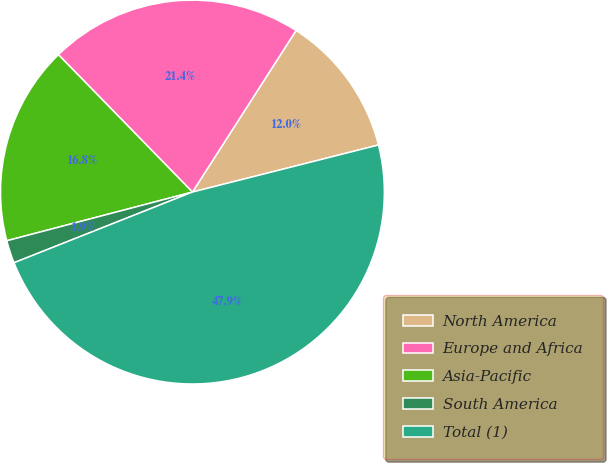<chart> <loc_0><loc_0><loc_500><loc_500><pie_chart><fcel>North America<fcel>Europe and Africa<fcel>Asia-Pacific<fcel>South America<fcel>Total (1)<nl><fcel>11.98%<fcel>21.38%<fcel>16.78%<fcel>1.92%<fcel>47.94%<nl></chart> 